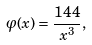Convert formula to latex. <formula><loc_0><loc_0><loc_500><loc_500>\varphi ( x ) = \frac { 1 4 4 } { x ^ { 3 } } ,</formula> 